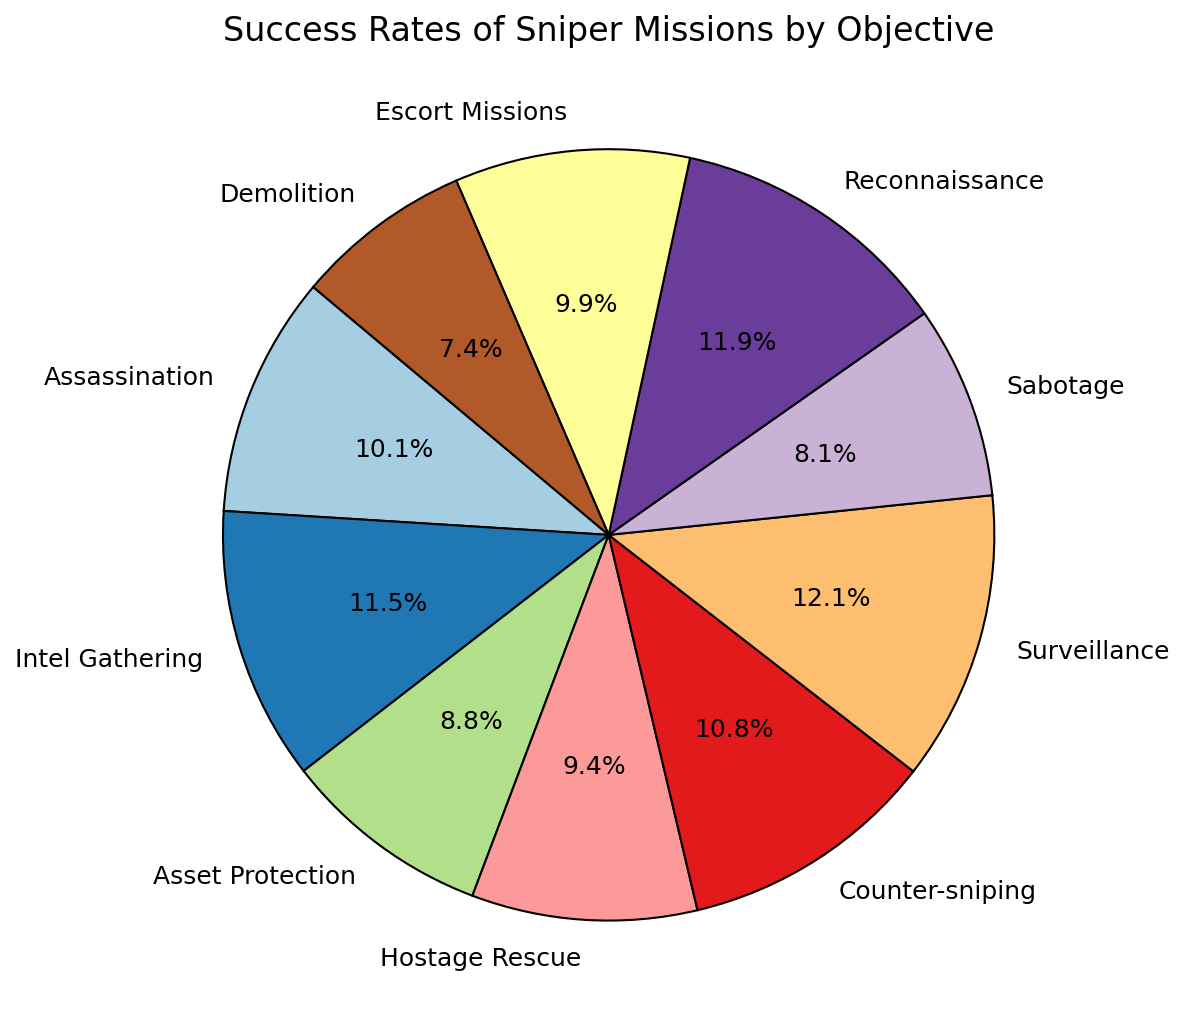Which mission objective has the highest success rate? The slice of the pie chart representing "Surveillance" is the largest, showing the highest percentage of 90%.
Answer: Surveillance Which mission objective has the lowest success rate? The smallest slice of the pie chart represents "Demolition", with the lowest success rate of 55%.
Answer: Demolition How much higher is the success rate of Intel Gathering compared to Sabotage? The success rate for Intel Gathering is 85%, and for Sabotage, it is 60%. The difference between them is 85% - 60%.
Answer: 25% What is the average success rate for the objectives Assassination, Hostage Rescue, and Counter-sniping? To find the average: (Success rate of Assassination + Success rate of Hostage Rescue + Success rate of Counter-sniping) / 3 = (75% + 70% + 80%) / 3 = 225 / 3.
Answer: 75% Which mission objectives have a success rate above 80%? The mission objectives with success rates above 80% are those represented by slices larger than 80% on the pie chart. These include Intel Gathering (85%), Counter-sniping (80%), Surveillance (90%), and Reconnaissance (88%).
Answer: Intel Gathering, Counter-sniping, Surveillance, Reconnaissance What is the combined success rate of Asset Protection and Escort Missions? The success rate of Asset Protection is 65%, and for Escort Missions, it is 73%. Therefore, the combined success rate is 65% + 73%.
Answer: 138% Is the success rate of Assassination higher or lower than Hostage Rescue? The success rate of Assassination is 75%, and Hostage Rescue is 70%. Thus, Assassination's success rate is higher.
Answer: Higher Which two mission objectives' success rates add up closest to 150%? By adding pairs of success rates, the pair that sums closest to 150% is Intel Gathering (85%) + Counter-sniping (80%). Their sum is 165%, which is closest to 150%.
Answer: Intel Gathering and Counter-sniping 